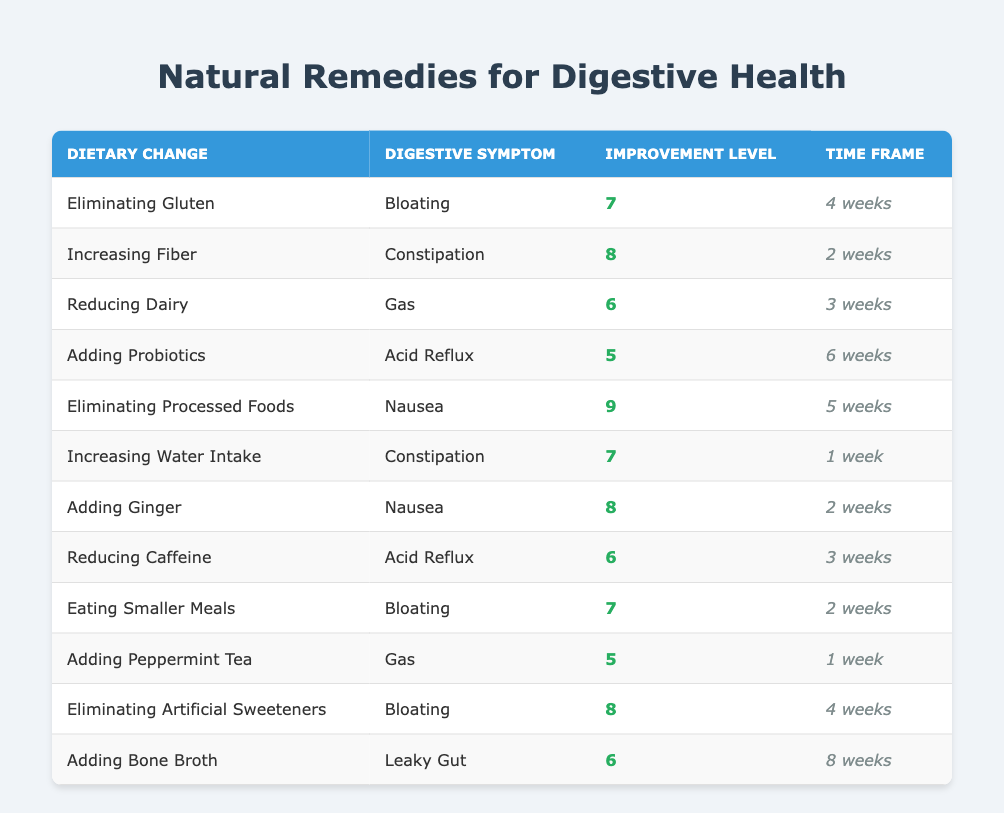What is the improvement level for eliminating gluten as a dietary change? The table shows the improvement level for "Eliminating Gluten" specifically in the "Improvement Level" column, which is listed as 7.
Answer: 7 Which dietary change has the highest improvement level? By comparing the "Improvement Level" values across all dietary changes, "Eliminating Processed Foods" has the highest improvement level at 9.
Answer: 9 Is there a dietary change that improves bloating and has an improvement level greater than 7? The table shows two changes for bloating: "Eliminating Gluten" with an improvement level of 7 and "Eating Smaller Meals" also with 7, but none exceed it.
Answer: No What is the time frame for seeing improvement from adding ginger? The "Time Frame" column specifies that improvement from "Adding Ginger" takes 2 weeks.
Answer: 2 weeks What is the average improvement level for digestive symptoms categorized as nausea? There are two entries for nausea: "Eliminating Processed Foods" (9) and "Adding Ginger" (8). To find the average: (9 + 8) / 2 = 8.5.
Answer: 8.5 Which dietary change related to acid reflux has a lower improvement level, reducing caffeine or adding probiotics? The improvement level for "Reducing Caffeine" is 6, while for "Adding Probiotics" it is 5. So, "Adding Probiotics" has the lower value.
Answer: Adding Probiotics How many weeks does it take to see improvement from increasing water intake? The "Time Frame" for "Increasing Water Intake" is specifically stated in the "Time Frame" column as 1 week.
Answer: 1 week Is there any dietary change that focuses on both constipation and has an improvement level of 7 or higher? The data indicates "Increasing Fiber" has an improvement level of 8 and "Increasing Water Intake" has 7, both addressing constipation.
Answer: Yes What is the most common digestive symptom addressed in the table? By reviewing the digestive symptoms listed, "Bloating" appears three times, indicating it is the most common symptom addressed.
Answer: Bloating 